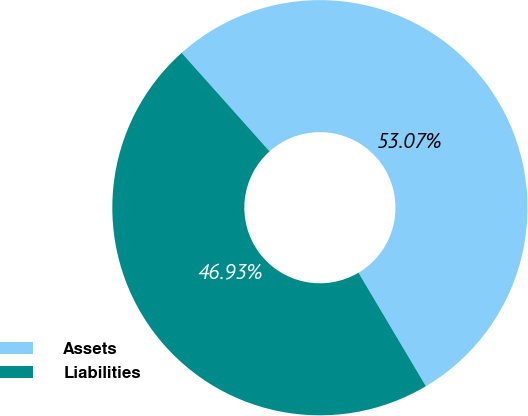Convert chart. <chart><loc_0><loc_0><loc_500><loc_500><pie_chart><fcel>Assets<fcel>Liabilities<nl><fcel>53.07%<fcel>46.93%<nl></chart> 